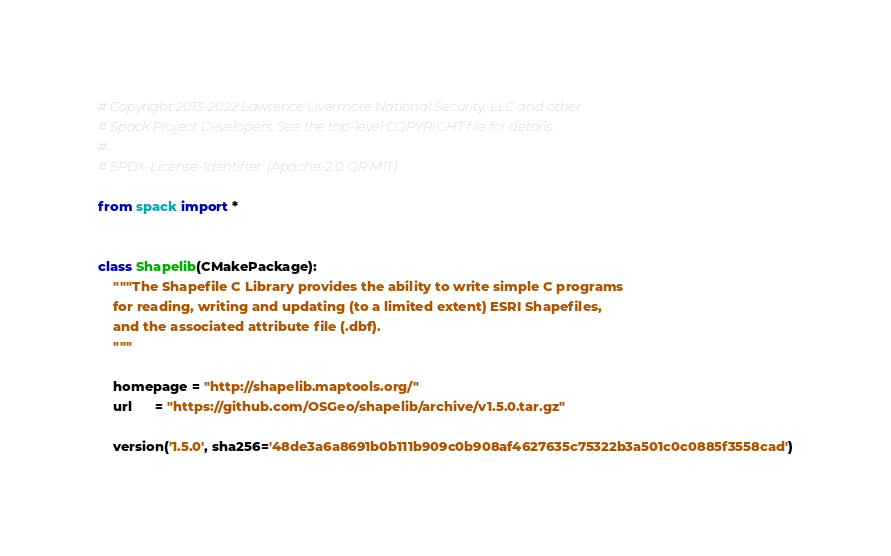Convert code to text. <code><loc_0><loc_0><loc_500><loc_500><_Python_># Copyright 2013-2022 Lawrence Livermore National Security, LLC and other
# Spack Project Developers. See the top-level COPYRIGHT file for details.
#
# SPDX-License-Identifier: (Apache-2.0 OR MIT)

from spack import *


class Shapelib(CMakePackage):
    """The Shapefile C Library provides the ability to write simple C programs
    for reading, writing and updating (to a limited extent) ESRI Shapefiles,
    and the associated attribute file (.dbf).
    """

    homepage = "http://shapelib.maptools.org/"
    url      = "https://github.com/OSGeo/shapelib/archive/v1.5.0.tar.gz"

    version('1.5.0', sha256='48de3a6a8691b0b111b909c0b908af4627635c75322b3a501c0c0885f3558cad')
</code> 